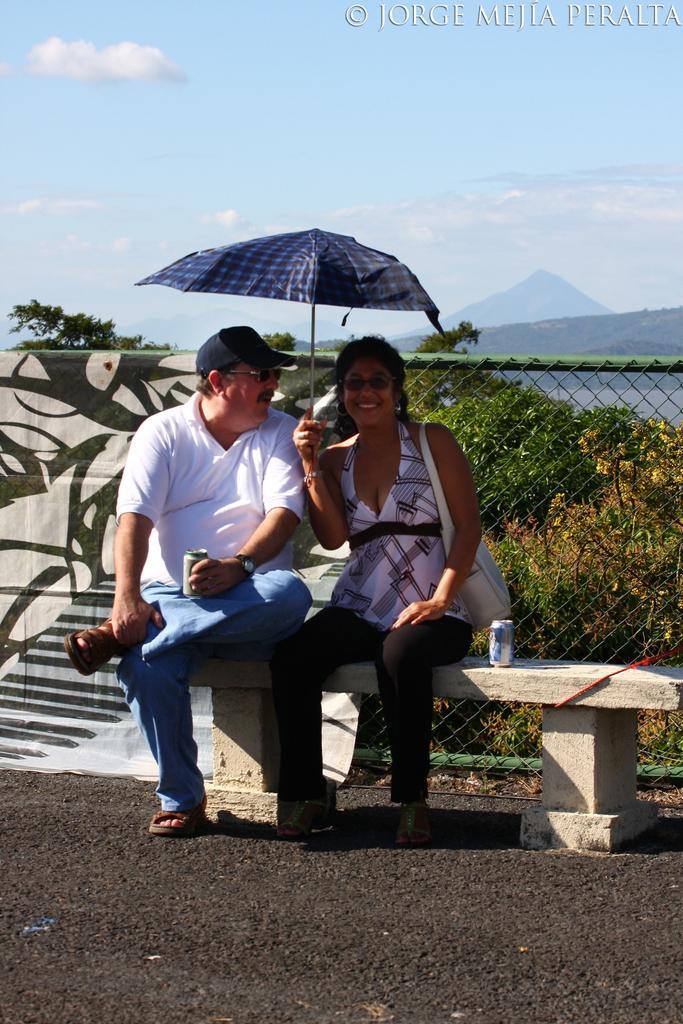Can you describe this image briefly? In this image there are two persons sitting on a cement table in the middle, and there are some trees and fencing at the right side of this image. There is a sky at the top of this image. 